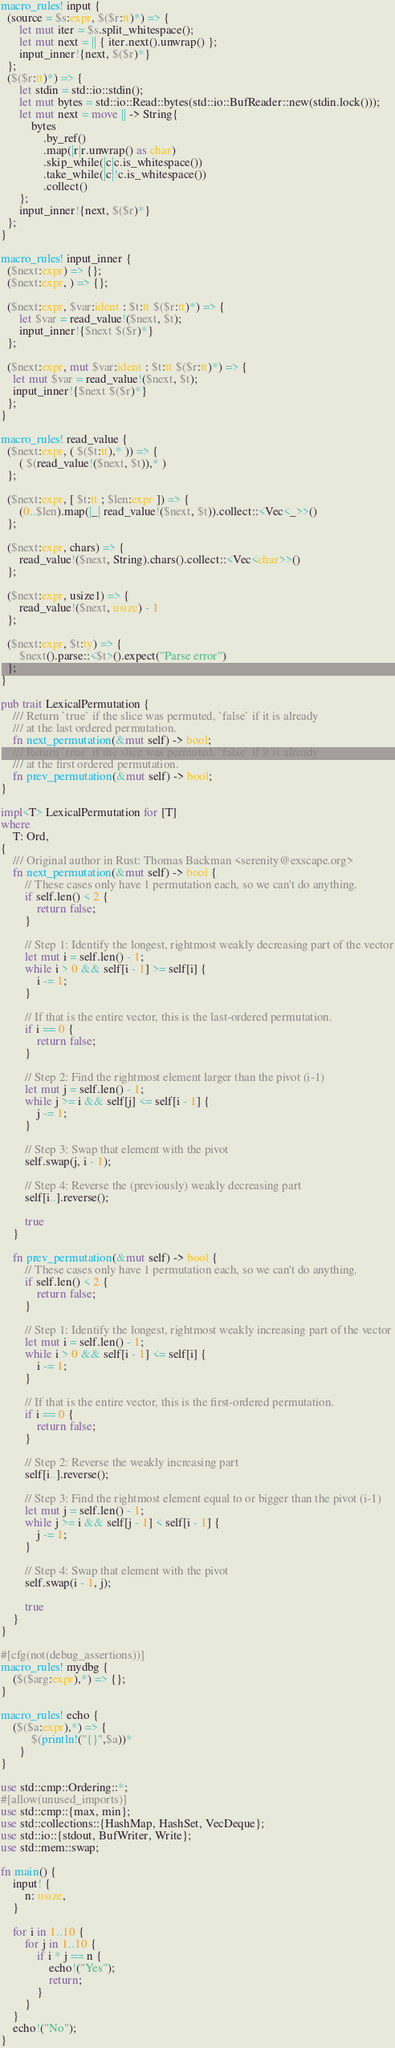<code> <loc_0><loc_0><loc_500><loc_500><_Rust_>macro_rules! input {
  (source = $s:expr, $($r:tt)*) => {
      let mut iter = $s.split_whitespace();
      let mut next = || { iter.next().unwrap() };
      input_inner!{next, $($r)*}
  };
  ($($r:tt)*) => {
      let stdin = std::io::stdin();
      let mut bytes = std::io::Read::bytes(std::io::BufReader::new(stdin.lock()));
      let mut next = move || -> String{
          bytes
              .by_ref()
              .map(|r|r.unwrap() as char)
              .skip_while(|c|c.is_whitespace())
              .take_while(|c|!c.is_whitespace())
              .collect()
      };
      input_inner!{next, $($r)*}
  };
}

macro_rules! input_inner {
  ($next:expr) => {};
  ($next:expr, ) => {};

  ($next:expr, $var:ident : $t:tt $($r:tt)*) => {
      let $var = read_value!($next, $t);
      input_inner!{$next $($r)*}
  };

  ($next:expr, mut $var:ident : $t:tt $($r:tt)*) => {
    let mut $var = read_value!($next, $t);
    input_inner!{$next $($r)*}
  };
}

macro_rules! read_value {
  ($next:expr, ( $($t:tt),* )) => {
      ( $(read_value!($next, $t)),* )
  };

  ($next:expr, [ $t:tt ; $len:expr ]) => {
      (0..$len).map(|_| read_value!($next, $t)).collect::<Vec<_>>()
  };

  ($next:expr, chars) => {
      read_value!($next, String).chars().collect::<Vec<char>>()
  };

  ($next:expr, usize1) => {
      read_value!($next, usize) - 1
  };

  ($next:expr, $t:ty) => {
      $next().parse::<$t>().expect("Parse error")
  };
}

pub trait LexicalPermutation {
    /// Return `true` if the slice was permuted, `false` if it is already
    /// at the last ordered permutation.
    fn next_permutation(&mut self) -> bool;
    /// Return `true` if the slice was permuted, `false` if it is already
    /// at the first ordered permutation.
    fn prev_permutation(&mut self) -> bool;
}

impl<T> LexicalPermutation for [T]
where
    T: Ord,
{
    /// Original author in Rust: Thomas Backman <serenity@exscape.org>
    fn next_permutation(&mut self) -> bool {
        // These cases only have 1 permutation each, so we can't do anything.
        if self.len() < 2 {
            return false;
        }

        // Step 1: Identify the longest, rightmost weakly decreasing part of the vector
        let mut i = self.len() - 1;
        while i > 0 && self[i - 1] >= self[i] {
            i -= 1;
        }

        // If that is the entire vector, this is the last-ordered permutation.
        if i == 0 {
            return false;
        }

        // Step 2: Find the rightmost element larger than the pivot (i-1)
        let mut j = self.len() - 1;
        while j >= i && self[j] <= self[i - 1] {
            j -= 1;
        }

        // Step 3: Swap that element with the pivot
        self.swap(j, i - 1);

        // Step 4: Reverse the (previously) weakly decreasing part
        self[i..].reverse();

        true
    }

    fn prev_permutation(&mut self) -> bool {
        // These cases only have 1 permutation each, so we can't do anything.
        if self.len() < 2 {
            return false;
        }

        // Step 1: Identify the longest, rightmost weakly increasing part of the vector
        let mut i = self.len() - 1;
        while i > 0 && self[i - 1] <= self[i] {
            i -= 1;
        }

        // If that is the entire vector, this is the first-ordered permutation.
        if i == 0 {
            return false;
        }

        // Step 2: Reverse the weakly increasing part
        self[i..].reverse();

        // Step 3: Find the rightmost element equal to or bigger than the pivot (i-1)
        let mut j = self.len() - 1;
        while j >= i && self[j - 1] < self[i - 1] {
            j -= 1;
        }

        // Step 4: Swap that element with the pivot
        self.swap(i - 1, j);

        true
    }
}

#[cfg(not(debug_assertions))]
macro_rules! mydbg {
    ($($arg:expr),*) => {};
}

macro_rules! echo {
    ($($a:expr),*) => {
          $(println!("{}",$a))*
      }
}

use std::cmp::Ordering::*;
#[allow(unused_imports)]
use std::cmp::{max, min};
use std::collections::{HashMap, HashSet, VecDeque};
use std::io::{stdout, BufWriter, Write};
use std::mem::swap;

fn main() {
    input! {
        n: usize,
    }

    for i in 1..10 {
        for j in 1..10 {
            if i * j == n {
                echo!("Yes");
                return;
            }
        }
    }
    echo!("No");
}</code> 